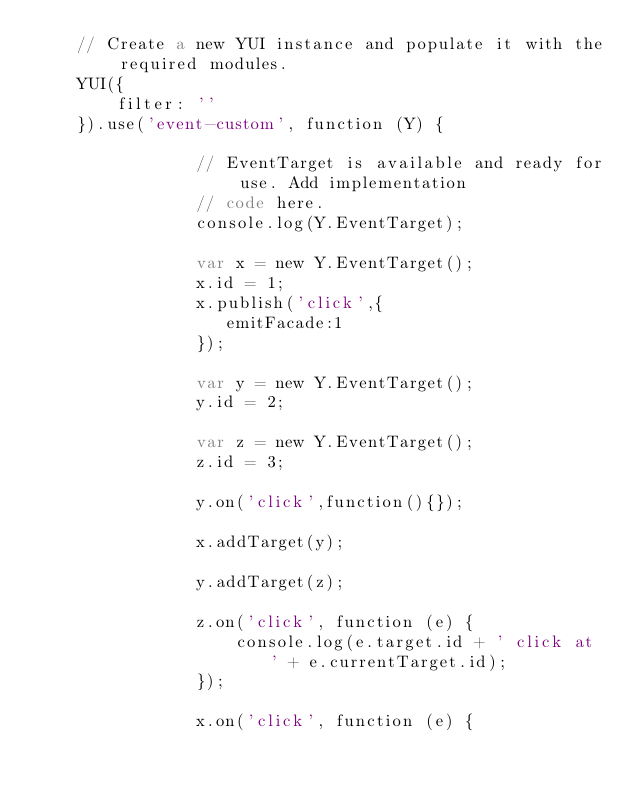Convert code to text. <code><loc_0><loc_0><loc_500><loc_500><_HTML_>    // Create a new YUI instance and populate it with the required modules.
    YUI({
        filter: ''
    }).use('event-custom', function (Y) {

                // EventTarget is available and ready for use. Add implementation
                // code here.
                console.log(Y.EventTarget);

                var x = new Y.EventTarget();
                x.id = 1;
                x.publish('click',{
                   emitFacade:1
                });

                var y = new Y.EventTarget();
                y.id = 2;

                var z = new Y.EventTarget();
                z.id = 3;

                y.on('click',function(){});

                x.addTarget(y);

                y.addTarget(z);

                z.on('click', function (e) {
                    console.log(e.target.id + ' click at ' + e.currentTarget.id);
                });

                x.on('click', function (e) {</code> 